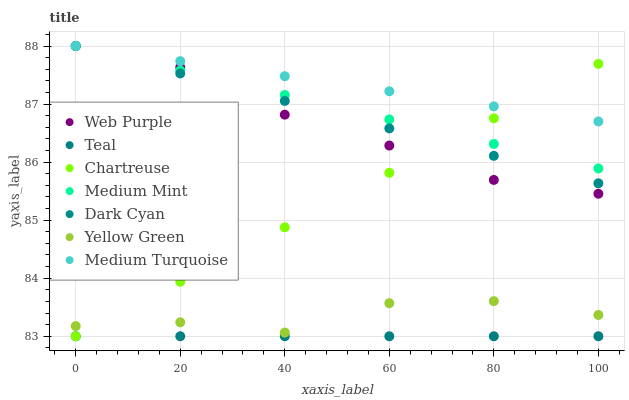Does Teal have the minimum area under the curve?
Answer yes or no. Yes. Does Medium Turquoise have the maximum area under the curve?
Answer yes or no. Yes. Does Yellow Green have the minimum area under the curve?
Answer yes or no. No. Does Yellow Green have the maximum area under the curve?
Answer yes or no. No. Is Teal the smoothest?
Answer yes or no. Yes. Is Yellow Green the roughest?
Answer yes or no. Yes. Is Medium Turquoise the smoothest?
Answer yes or no. No. Is Medium Turquoise the roughest?
Answer yes or no. No. Does Chartreuse have the lowest value?
Answer yes or no. Yes. Does Yellow Green have the lowest value?
Answer yes or no. No. Does Dark Cyan have the highest value?
Answer yes or no. Yes. Does Yellow Green have the highest value?
Answer yes or no. No. Is Yellow Green less than Web Purple?
Answer yes or no. Yes. Is Medium Mint greater than Yellow Green?
Answer yes or no. Yes. Does Medium Turquoise intersect Web Purple?
Answer yes or no. Yes. Is Medium Turquoise less than Web Purple?
Answer yes or no. No. Is Medium Turquoise greater than Web Purple?
Answer yes or no. No. Does Yellow Green intersect Web Purple?
Answer yes or no. No. 